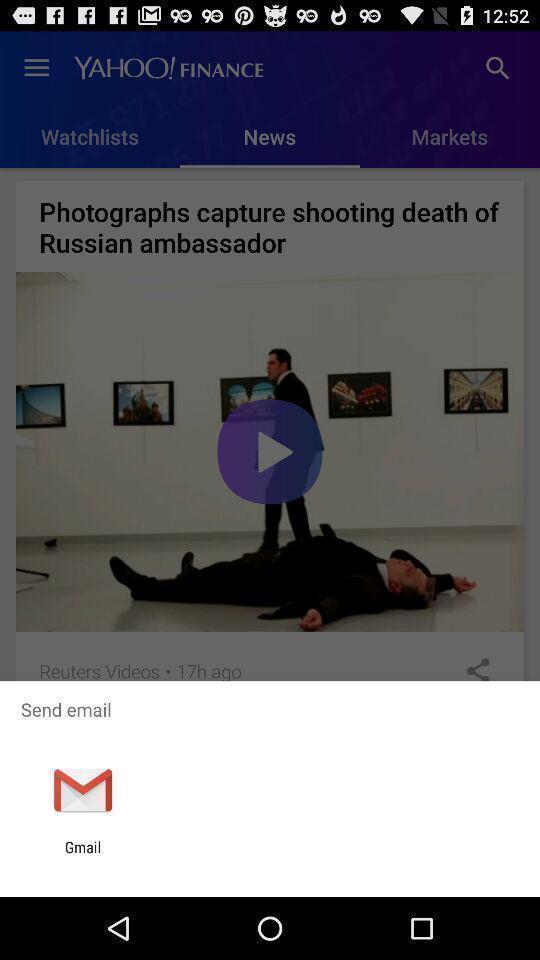What can you discern from this picture? Pop-up to send email via app. 